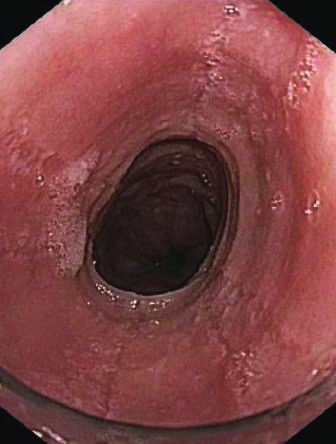does the atrium reveal circumferential rings in the proximal esophagus of this patient with eosinophilic esophagitis?
Answer the question using a single word or phrase. No 